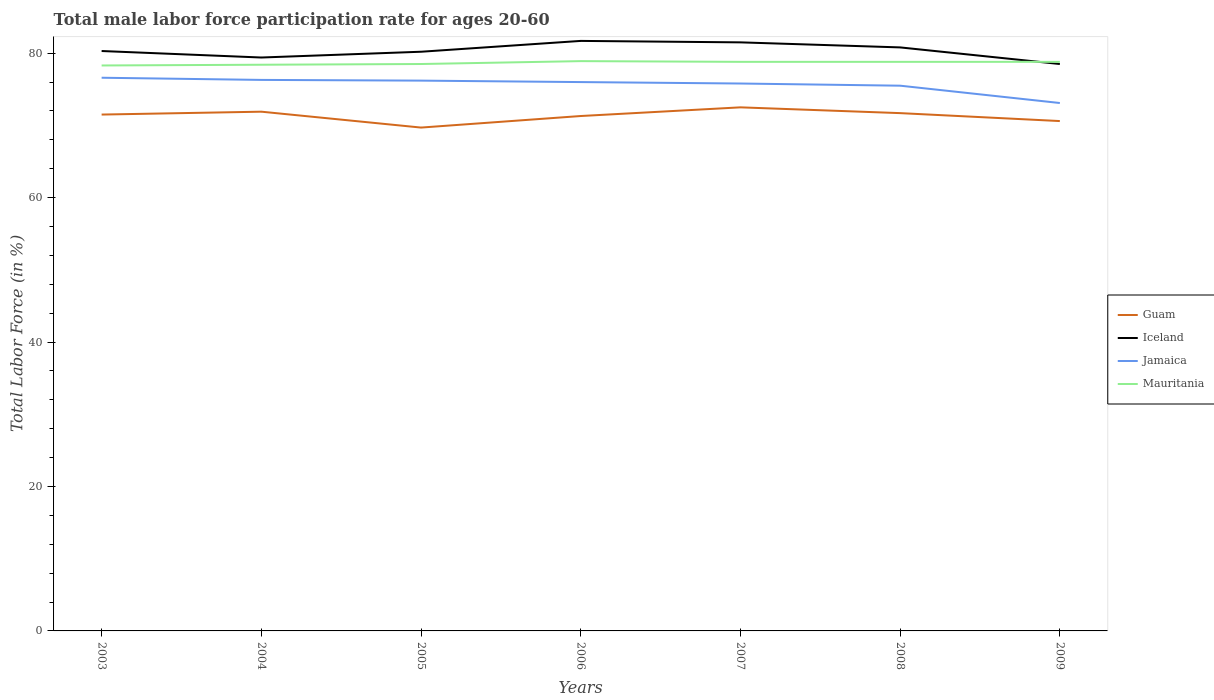How many different coloured lines are there?
Your answer should be very brief. 4. Across all years, what is the maximum male labor force participation rate in Guam?
Give a very brief answer. 69.7. In which year was the male labor force participation rate in Iceland maximum?
Make the answer very short. 2009. What is the difference between the highest and the second highest male labor force participation rate in Jamaica?
Provide a short and direct response. 3.5. What is the difference between the highest and the lowest male labor force participation rate in Iceland?
Keep it short and to the point. 3. Is the male labor force participation rate in Mauritania strictly greater than the male labor force participation rate in Iceland over the years?
Provide a short and direct response. No. How many lines are there?
Your answer should be very brief. 4. How many years are there in the graph?
Keep it short and to the point. 7. What is the difference between two consecutive major ticks on the Y-axis?
Your response must be concise. 20. Are the values on the major ticks of Y-axis written in scientific E-notation?
Give a very brief answer. No. Does the graph contain grids?
Offer a very short reply. No. Where does the legend appear in the graph?
Give a very brief answer. Center right. How many legend labels are there?
Offer a very short reply. 4. How are the legend labels stacked?
Offer a terse response. Vertical. What is the title of the graph?
Ensure brevity in your answer.  Total male labor force participation rate for ages 20-60. Does "Timor-Leste" appear as one of the legend labels in the graph?
Ensure brevity in your answer.  No. What is the label or title of the X-axis?
Provide a short and direct response. Years. What is the label or title of the Y-axis?
Your answer should be very brief. Total Labor Force (in %). What is the Total Labor Force (in %) in Guam in 2003?
Provide a short and direct response. 71.5. What is the Total Labor Force (in %) in Iceland in 2003?
Your response must be concise. 80.3. What is the Total Labor Force (in %) in Jamaica in 2003?
Offer a very short reply. 76.6. What is the Total Labor Force (in %) in Mauritania in 2003?
Your answer should be very brief. 78.3. What is the Total Labor Force (in %) in Guam in 2004?
Offer a very short reply. 71.9. What is the Total Labor Force (in %) in Iceland in 2004?
Your answer should be very brief. 79.4. What is the Total Labor Force (in %) of Jamaica in 2004?
Provide a short and direct response. 76.3. What is the Total Labor Force (in %) in Mauritania in 2004?
Ensure brevity in your answer.  78.4. What is the Total Labor Force (in %) of Guam in 2005?
Ensure brevity in your answer.  69.7. What is the Total Labor Force (in %) in Iceland in 2005?
Keep it short and to the point. 80.2. What is the Total Labor Force (in %) in Jamaica in 2005?
Offer a terse response. 76.2. What is the Total Labor Force (in %) in Mauritania in 2005?
Keep it short and to the point. 78.5. What is the Total Labor Force (in %) in Guam in 2006?
Make the answer very short. 71.3. What is the Total Labor Force (in %) in Iceland in 2006?
Offer a very short reply. 81.7. What is the Total Labor Force (in %) of Mauritania in 2006?
Your answer should be compact. 78.9. What is the Total Labor Force (in %) in Guam in 2007?
Your answer should be very brief. 72.5. What is the Total Labor Force (in %) in Iceland in 2007?
Provide a succinct answer. 81.5. What is the Total Labor Force (in %) in Jamaica in 2007?
Ensure brevity in your answer.  75.8. What is the Total Labor Force (in %) in Mauritania in 2007?
Give a very brief answer. 78.8. What is the Total Labor Force (in %) in Guam in 2008?
Your response must be concise. 71.7. What is the Total Labor Force (in %) in Iceland in 2008?
Your answer should be compact. 80.8. What is the Total Labor Force (in %) in Jamaica in 2008?
Your response must be concise. 75.5. What is the Total Labor Force (in %) in Mauritania in 2008?
Your answer should be compact. 78.8. What is the Total Labor Force (in %) of Guam in 2009?
Your answer should be compact. 70.6. What is the Total Labor Force (in %) of Iceland in 2009?
Offer a very short reply. 78.5. What is the Total Labor Force (in %) in Jamaica in 2009?
Provide a short and direct response. 73.1. What is the Total Labor Force (in %) of Mauritania in 2009?
Your answer should be compact. 78.8. Across all years, what is the maximum Total Labor Force (in %) in Guam?
Make the answer very short. 72.5. Across all years, what is the maximum Total Labor Force (in %) in Iceland?
Ensure brevity in your answer.  81.7. Across all years, what is the maximum Total Labor Force (in %) of Jamaica?
Keep it short and to the point. 76.6. Across all years, what is the maximum Total Labor Force (in %) of Mauritania?
Keep it short and to the point. 78.9. Across all years, what is the minimum Total Labor Force (in %) of Guam?
Ensure brevity in your answer.  69.7. Across all years, what is the minimum Total Labor Force (in %) in Iceland?
Provide a short and direct response. 78.5. Across all years, what is the minimum Total Labor Force (in %) in Jamaica?
Your answer should be very brief. 73.1. Across all years, what is the minimum Total Labor Force (in %) in Mauritania?
Your response must be concise. 78.3. What is the total Total Labor Force (in %) in Guam in the graph?
Provide a short and direct response. 499.2. What is the total Total Labor Force (in %) in Iceland in the graph?
Offer a terse response. 562.4. What is the total Total Labor Force (in %) of Jamaica in the graph?
Offer a very short reply. 529.5. What is the total Total Labor Force (in %) of Mauritania in the graph?
Your answer should be compact. 550.5. What is the difference between the Total Labor Force (in %) in Guam in 2003 and that in 2004?
Provide a short and direct response. -0.4. What is the difference between the Total Labor Force (in %) of Iceland in 2003 and that in 2004?
Provide a succinct answer. 0.9. What is the difference between the Total Labor Force (in %) of Iceland in 2003 and that in 2005?
Make the answer very short. 0.1. What is the difference between the Total Labor Force (in %) in Iceland in 2003 and that in 2006?
Keep it short and to the point. -1.4. What is the difference between the Total Labor Force (in %) in Jamaica in 2003 and that in 2006?
Make the answer very short. 0.6. What is the difference between the Total Labor Force (in %) of Iceland in 2003 and that in 2007?
Make the answer very short. -1.2. What is the difference between the Total Labor Force (in %) in Jamaica in 2003 and that in 2007?
Your answer should be very brief. 0.8. What is the difference between the Total Labor Force (in %) in Mauritania in 2003 and that in 2007?
Keep it short and to the point. -0.5. What is the difference between the Total Labor Force (in %) in Iceland in 2003 and that in 2008?
Offer a terse response. -0.5. What is the difference between the Total Labor Force (in %) in Jamaica in 2003 and that in 2008?
Offer a very short reply. 1.1. What is the difference between the Total Labor Force (in %) in Iceland in 2003 and that in 2009?
Your answer should be very brief. 1.8. What is the difference between the Total Labor Force (in %) in Iceland in 2004 and that in 2005?
Your response must be concise. -0.8. What is the difference between the Total Labor Force (in %) of Guam in 2004 and that in 2006?
Offer a very short reply. 0.6. What is the difference between the Total Labor Force (in %) in Jamaica in 2004 and that in 2006?
Make the answer very short. 0.3. What is the difference between the Total Labor Force (in %) in Guam in 2004 and that in 2007?
Your answer should be very brief. -0.6. What is the difference between the Total Labor Force (in %) in Jamaica in 2004 and that in 2007?
Make the answer very short. 0.5. What is the difference between the Total Labor Force (in %) in Guam in 2004 and that in 2008?
Your answer should be very brief. 0.2. What is the difference between the Total Labor Force (in %) in Jamaica in 2004 and that in 2008?
Offer a terse response. 0.8. What is the difference between the Total Labor Force (in %) in Mauritania in 2004 and that in 2008?
Provide a short and direct response. -0.4. What is the difference between the Total Labor Force (in %) in Guam in 2004 and that in 2009?
Ensure brevity in your answer.  1.3. What is the difference between the Total Labor Force (in %) in Guam in 2005 and that in 2006?
Your answer should be very brief. -1.6. What is the difference between the Total Labor Force (in %) of Jamaica in 2005 and that in 2006?
Your answer should be very brief. 0.2. What is the difference between the Total Labor Force (in %) in Mauritania in 2005 and that in 2006?
Give a very brief answer. -0.4. What is the difference between the Total Labor Force (in %) in Jamaica in 2005 and that in 2007?
Offer a terse response. 0.4. What is the difference between the Total Labor Force (in %) in Guam in 2005 and that in 2008?
Give a very brief answer. -2. What is the difference between the Total Labor Force (in %) in Iceland in 2005 and that in 2008?
Keep it short and to the point. -0.6. What is the difference between the Total Labor Force (in %) in Mauritania in 2005 and that in 2008?
Provide a succinct answer. -0.3. What is the difference between the Total Labor Force (in %) of Guam in 2005 and that in 2009?
Offer a very short reply. -0.9. What is the difference between the Total Labor Force (in %) of Iceland in 2005 and that in 2009?
Your response must be concise. 1.7. What is the difference between the Total Labor Force (in %) of Guam in 2006 and that in 2007?
Your answer should be compact. -1.2. What is the difference between the Total Labor Force (in %) of Jamaica in 2006 and that in 2007?
Your answer should be very brief. 0.2. What is the difference between the Total Labor Force (in %) of Guam in 2006 and that in 2008?
Offer a terse response. -0.4. What is the difference between the Total Labor Force (in %) in Guam in 2006 and that in 2009?
Your answer should be very brief. 0.7. What is the difference between the Total Labor Force (in %) of Mauritania in 2006 and that in 2009?
Offer a very short reply. 0.1. What is the difference between the Total Labor Force (in %) of Iceland in 2007 and that in 2008?
Provide a short and direct response. 0.7. What is the difference between the Total Labor Force (in %) in Jamaica in 2007 and that in 2008?
Make the answer very short. 0.3. What is the difference between the Total Labor Force (in %) in Mauritania in 2007 and that in 2009?
Provide a succinct answer. 0. What is the difference between the Total Labor Force (in %) in Guam in 2008 and that in 2009?
Offer a terse response. 1.1. What is the difference between the Total Labor Force (in %) of Iceland in 2008 and that in 2009?
Your answer should be compact. 2.3. What is the difference between the Total Labor Force (in %) in Jamaica in 2008 and that in 2009?
Your response must be concise. 2.4. What is the difference between the Total Labor Force (in %) in Mauritania in 2008 and that in 2009?
Your answer should be very brief. 0. What is the difference between the Total Labor Force (in %) in Guam in 2003 and the Total Labor Force (in %) in Iceland in 2004?
Keep it short and to the point. -7.9. What is the difference between the Total Labor Force (in %) in Guam in 2003 and the Total Labor Force (in %) in Mauritania in 2004?
Provide a short and direct response. -6.9. What is the difference between the Total Labor Force (in %) of Iceland in 2003 and the Total Labor Force (in %) of Jamaica in 2004?
Offer a very short reply. 4. What is the difference between the Total Labor Force (in %) in Jamaica in 2003 and the Total Labor Force (in %) in Mauritania in 2004?
Give a very brief answer. -1.8. What is the difference between the Total Labor Force (in %) in Guam in 2003 and the Total Labor Force (in %) in Iceland in 2005?
Provide a succinct answer. -8.7. What is the difference between the Total Labor Force (in %) of Iceland in 2003 and the Total Labor Force (in %) of Mauritania in 2005?
Offer a very short reply. 1.8. What is the difference between the Total Labor Force (in %) of Jamaica in 2003 and the Total Labor Force (in %) of Mauritania in 2005?
Provide a succinct answer. -1.9. What is the difference between the Total Labor Force (in %) in Guam in 2003 and the Total Labor Force (in %) in Jamaica in 2006?
Your response must be concise. -4.5. What is the difference between the Total Labor Force (in %) in Guam in 2003 and the Total Labor Force (in %) in Mauritania in 2006?
Keep it short and to the point. -7.4. What is the difference between the Total Labor Force (in %) of Iceland in 2003 and the Total Labor Force (in %) of Mauritania in 2006?
Provide a short and direct response. 1.4. What is the difference between the Total Labor Force (in %) in Jamaica in 2003 and the Total Labor Force (in %) in Mauritania in 2006?
Provide a short and direct response. -2.3. What is the difference between the Total Labor Force (in %) in Guam in 2003 and the Total Labor Force (in %) in Iceland in 2007?
Make the answer very short. -10. What is the difference between the Total Labor Force (in %) in Guam in 2003 and the Total Labor Force (in %) in Jamaica in 2007?
Provide a succinct answer. -4.3. What is the difference between the Total Labor Force (in %) in Guam in 2003 and the Total Labor Force (in %) in Iceland in 2008?
Offer a very short reply. -9.3. What is the difference between the Total Labor Force (in %) of Guam in 2003 and the Total Labor Force (in %) of Jamaica in 2008?
Give a very brief answer. -4. What is the difference between the Total Labor Force (in %) in Guam in 2003 and the Total Labor Force (in %) in Mauritania in 2008?
Keep it short and to the point. -7.3. What is the difference between the Total Labor Force (in %) of Iceland in 2003 and the Total Labor Force (in %) of Jamaica in 2008?
Ensure brevity in your answer.  4.8. What is the difference between the Total Labor Force (in %) of Iceland in 2003 and the Total Labor Force (in %) of Mauritania in 2009?
Give a very brief answer. 1.5. What is the difference between the Total Labor Force (in %) of Jamaica in 2003 and the Total Labor Force (in %) of Mauritania in 2009?
Provide a short and direct response. -2.2. What is the difference between the Total Labor Force (in %) in Guam in 2004 and the Total Labor Force (in %) in Iceland in 2005?
Your answer should be compact. -8.3. What is the difference between the Total Labor Force (in %) in Iceland in 2004 and the Total Labor Force (in %) in Jamaica in 2005?
Make the answer very short. 3.2. What is the difference between the Total Labor Force (in %) in Jamaica in 2004 and the Total Labor Force (in %) in Mauritania in 2005?
Provide a succinct answer. -2.2. What is the difference between the Total Labor Force (in %) of Guam in 2004 and the Total Labor Force (in %) of Iceland in 2006?
Provide a short and direct response. -9.8. What is the difference between the Total Labor Force (in %) in Guam in 2004 and the Total Labor Force (in %) in Jamaica in 2006?
Your response must be concise. -4.1. What is the difference between the Total Labor Force (in %) of Iceland in 2004 and the Total Labor Force (in %) of Jamaica in 2006?
Give a very brief answer. 3.4. What is the difference between the Total Labor Force (in %) in Iceland in 2004 and the Total Labor Force (in %) in Mauritania in 2006?
Make the answer very short. 0.5. What is the difference between the Total Labor Force (in %) of Jamaica in 2004 and the Total Labor Force (in %) of Mauritania in 2006?
Provide a short and direct response. -2.6. What is the difference between the Total Labor Force (in %) in Guam in 2004 and the Total Labor Force (in %) in Iceland in 2007?
Ensure brevity in your answer.  -9.6. What is the difference between the Total Labor Force (in %) of Iceland in 2004 and the Total Labor Force (in %) of Jamaica in 2007?
Ensure brevity in your answer.  3.6. What is the difference between the Total Labor Force (in %) of Iceland in 2004 and the Total Labor Force (in %) of Mauritania in 2007?
Offer a terse response. 0.6. What is the difference between the Total Labor Force (in %) in Iceland in 2004 and the Total Labor Force (in %) in Jamaica in 2008?
Your answer should be very brief. 3.9. What is the difference between the Total Labor Force (in %) of Jamaica in 2004 and the Total Labor Force (in %) of Mauritania in 2008?
Ensure brevity in your answer.  -2.5. What is the difference between the Total Labor Force (in %) in Guam in 2004 and the Total Labor Force (in %) in Iceland in 2009?
Offer a terse response. -6.6. What is the difference between the Total Labor Force (in %) of Guam in 2004 and the Total Labor Force (in %) of Jamaica in 2009?
Make the answer very short. -1.2. What is the difference between the Total Labor Force (in %) in Guam in 2004 and the Total Labor Force (in %) in Mauritania in 2009?
Give a very brief answer. -6.9. What is the difference between the Total Labor Force (in %) of Iceland in 2004 and the Total Labor Force (in %) of Jamaica in 2009?
Ensure brevity in your answer.  6.3. What is the difference between the Total Labor Force (in %) in Iceland in 2004 and the Total Labor Force (in %) in Mauritania in 2009?
Give a very brief answer. 0.6. What is the difference between the Total Labor Force (in %) in Jamaica in 2004 and the Total Labor Force (in %) in Mauritania in 2009?
Offer a terse response. -2.5. What is the difference between the Total Labor Force (in %) of Guam in 2005 and the Total Labor Force (in %) of Iceland in 2006?
Provide a short and direct response. -12. What is the difference between the Total Labor Force (in %) in Guam in 2005 and the Total Labor Force (in %) in Jamaica in 2006?
Make the answer very short. -6.3. What is the difference between the Total Labor Force (in %) of Guam in 2005 and the Total Labor Force (in %) of Mauritania in 2006?
Your answer should be compact. -9.2. What is the difference between the Total Labor Force (in %) of Jamaica in 2005 and the Total Labor Force (in %) of Mauritania in 2006?
Keep it short and to the point. -2.7. What is the difference between the Total Labor Force (in %) in Guam in 2005 and the Total Labor Force (in %) in Iceland in 2007?
Your answer should be compact. -11.8. What is the difference between the Total Labor Force (in %) of Guam in 2005 and the Total Labor Force (in %) of Jamaica in 2007?
Offer a very short reply. -6.1. What is the difference between the Total Labor Force (in %) in Guam in 2005 and the Total Labor Force (in %) in Mauritania in 2007?
Ensure brevity in your answer.  -9.1. What is the difference between the Total Labor Force (in %) in Guam in 2005 and the Total Labor Force (in %) in Jamaica in 2008?
Your answer should be very brief. -5.8. What is the difference between the Total Labor Force (in %) in Guam in 2005 and the Total Labor Force (in %) in Mauritania in 2008?
Offer a very short reply. -9.1. What is the difference between the Total Labor Force (in %) of Iceland in 2005 and the Total Labor Force (in %) of Jamaica in 2008?
Offer a terse response. 4.7. What is the difference between the Total Labor Force (in %) in Guam in 2005 and the Total Labor Force (in %) in Iceland in 2009?
Keep it short and to the point. -8.8. What is the difference between the Total Labor Force (in %) of Guam in 2005 and the Total Labor Force (in %) of Jamaica in 2009?
Offer a very short reply. -3.4. What is the difference between the Total Labor Force (in %) in Guam in 2005 and the Total Labor Force (in %) in Mauritania in 2009?
Provide a succinct answer. -9.1. What is the difference between the Total Labor Force (in %) of Jamaica in 2005 and the Total Labor Force (in %) of Mauritania in 2009?
Offer a terse response. -2.6. What is the difference between the Total Labor Force (in %) of Guam in 2006 and the Total Labor Force (in %) of Iceland in 2007?
Ensure brevity in your answer.  -10.2. What is the difference between the Total Labor Force (in %) in Guam in 2006 and the Total Labor Force (in %) in Jamaica in 2007?
Provide a succinct answer. -4.5. What is the difference between the Total Labor Force (in %) in Guam in 2006 and the Total Labor Force (in %) in Mauritania in 2007?
Provide a short and direct response. -7.5. What is the difference between the Total Labor Force (in %) of Iceland in 2006 and the Total Labor Force (in %) of Mauritania in 2007?
Make the answer very short. 2.9. What is the difference between the Total Labor Force (in %) of Guam in 2006 and the Total Labor Force (in %) of Iceland in 2008?
Offer a terse response. -9.5. What is the difference between the Total Labor Force (in %) of Guam in 2006 and the Total Labor Force (in %) of Jamaica in 2008?
Provide a succinct answer. -4.2. What is the difference between the Total Labor Force (in %) in Guam in 2006 and the Total Labor Force (in %) in Mauritania in 2008?
Provide a succinct answer. -7.5. What is the difference between the Total Labor Force (in %) in Guam in 2006 and the Total Labor Force (in %) in Iceland in 2009?
Keep it short and to the point. -7.2. What is the difference between the Total Labor Force (in %) in Guam in 2006 and the Total Labor Force (in %) in Mauritania in 2009?
Ensure brevity in your answer.  -7.5. What is the difference between the Total Labor Force (in %) of Iceland in 2006 and the Total Labor Force (in %) of Mauritania in 2009?
Offer a terse response. 2.9. What is the difference between the Total Labor Force (in %) in Jamaica in 2006 and the Total Labor Force (in %) in Mauritania in 2009?
Your answer should be very brief. -2.8. What is the difference between the Total Labor Force (in %) of Guam in 2007 and the Total Labor Force (in %) of Jamaica in 2008?
Offer a terse response. -3. What is the difference between the Total Labor Force (in %) in Iceland in 2007 and the Total Labor Force (in %) in Mauritania in 2008?
Ensure brevity in your answer.  2.7. What is the difference between the Total Labor Force (in %) of Guam in 2007 and the Total Labor Force (in %) of Jamaica in 2009?
Your answer should be compact. -0.6. What is the difference between the Total Labor Force (in %) in Iceland in 2007 and the Total Labor Force (in %) in Jamaica in 2009?
Give a very brief answer. 8.4. What is the difference between the Total Labor Force (in %) of Iceland in 2007 and the Total Labor Force (in %) of Mauritania in 2009?
Your answer should be compact. 2.7. What is the difference between the Total Labor Force (in %) in Jamaica in 2007 and the Total Labor Force (in %) in Mauritania in 2009?
Ensure brevity in your answer.  -3. What is the difference between the Total Labor Force (in %) of Guam in 2008 and the Total Labor Force (in %) of Iceland in 2009?
Provide a succinct answer. -6.8. What is the difference between the Total Labor Force (in %) in Guam in 2008 and the Total Labor Force (in %) in Mauritania in 2009?
Your answer should be very brief. -7.1. What is the difference between the Total Labor Force (in %) in Iceland in 2008 and the Total Labor Force (in %) in Mauritania in 2009?
Offer a terse response. 2. What is the average Total Labor Force (in %) of Guam per year?
Provide a succinct answer. 71.31. What is the average Total Labor Force (in %) in Iceland per year?
Your answer should be compact. 80.34. What is the average Total Labor Force (in %) in Jamaica per year?
Make the answer very short. 75.64. What is the average Total Labor Force (in %) in Mauritania per year?
Give a very brief answer. 78.64. In the year 2003, what is the difference between the Total Labor Force (in %) of Guam and Total Labor Force (in %) of Mauritania?
Ensure brevity in your answer.  -6.8. In the year 2003, what is the difference between the Total Labor Force (in %) in Iceland and Total Labor Force (in %) in Jamaica?
Offer a terse response. 3.7. In the year 2003, what is the difference between the Total Labor Force (in %) of Jamaica and Total Labor Force (in %) of Mauritania?
Make the answer very short. -1.7. In the year 2004, what is the difference between the Total Labor Force (in %) of Guam and Total Labor Force (in %) of Iceland?
Keep it short and to the point. -7.5. In the year 2004, what is the difference between the Total Labor Force (in %) of Iceland and Total Labor Force (in %) of Mauritania?
Offer a terse response. 1. In the year 2005, what is the difference between the Total Labor Force (in %) in Guam and Total Labor Force (in %) in Mauritania?
Ensure brevity in your answer.  -8.8. In the year 2005, what is the difference between the Total Labor Force (in %) in Iceland and Total Labor Force (in %) in Jamaica?
Provide a succinct answer. 4. In the year 2005, what is the difference between the Total Labor Force (in %) in Jamaica and Total Labor Force (in %) in Mauritania?
Offer a terse response. -2.3. In the year 2006, what is the difference between the Total Labor Force (in %) of Guam and Total Labor Force (in %) of Iceland?
Give a very brief answer. -10.4. In the year 2006, what is the difference between the Total Labor Force (in %) in Guam and Total Labor Force (in %) in Jamaica?
Make the answer very short. -4.7. In the year 2006, what is the difference between the Total Labor Force (in %) in Iceland and Total Labor Force (in %) in Jamaica?
Offer a very short reply. 5.7. In the year 2006, what is the difference between the Total Labor Force (in %) of Jamaica and Total Labor Force (in %) of Mauritania?
Ensure brevity in your answer.  -2.9. In the year 2007, what is the difference between the Total Labor Force (in %) of Guam and Total Labor Force (in %) of Iceland?
Provide a short and direct response. -9. In the year 2007, what is the difference between the Total Labor Force (in %) of Guam and Total Labor Force (in %) of Jamaica?
Your answer should be very brief. -3.3. In the year 2007, what is the difference between the Total Labor Force (in %) of Guam and Total Labor Force (in %) of Mauritania?
Give a very brief answer. -6.3. In the year 2007, what is the difference between the Total Labor Force (in %) in Iceland and Total Labor Force (in %) in Mauritania?
Offer a very short reply. 2.7. In the year 2008, what is the difference between the Total Labor Force (in %) of Guam and Total Labor Force (in %) of Mauritania?
Offer a terse response. -7.1. In the year 2008, what is the difference between the Total Labor Force (in %) in Iceland and Total Labor Force (in %) in Jamaica?
Your answer should be compact. 5.3. In the year 2008, what is the difference between the Total Labor Force (in %) in Iceland and Total Labor Force (in %) in Mauritania?
Make the answer very short. 2. In the year 2009, what is the difference between the Total Labor Force (in %) of Guam and Total Labor Force (in %) of Mauritania?
Ensure brevity in your answer.  -8.2. In the year 2009, what is the difference between the Total Labor Force (in %) in Iceland and Total Labor Force (in %) in Jamaica?
Your response must be concise. 5.4. In the year 2009, what is the difference between the Total Labor Force (in %) of Iceland and Total Labor Force (in %) of Mauritania?
Keep it short and to the point. -0.3. In the year 2009, what is the difference between the Total Labor Force (in %) of Jamaica and Total Labor Force (in %) of Mauritania?
Offer a very short reply. -5.7. What is the ratio of the Total Labor Force (in %) of Guam in 2003 to that in 2004?
Provide a short and direct response. 0.99. What is the ratio of the Total Labor Force (in %) of Iceland in 2003 to that in 2004?
Ensure brevity in your answer.  1.01. What is the ratio of the Total Labor Force (in %) of Guam in 2003 to that in 2005?
Offer a very short reply. 1.03. What is the ratio of the Total Labor Force (in %) of Iceland in 2003 to that in 2005?
Provide a succinct answer. 1. What is the ratio of the Total Labor Force (in %) of Jamaica in 2003 to that in 2005?
Offer a terse response. 1.01. What is the ratio of the Total Labor Force (in %) in Mauritania in 2003 to that in 2005?
Ensure brevity in your answer.  1. What is the ratio of the Total Labor Force (in %) of Iceland in 2003 to that in 2006?
Make the answer very short. 0.98. What is the ratio of the Total Labor Force (in %) in Jamaica in 2003 to that in 2006?
Ensure brevity in your answer.  1.01. What is the ratio of the Total Labor Force (in %) of Guam in 2003 to that in 2007?
Your answer should be very brief. 0.99. What is the ratio of the Total Labor Force (in %) of Iceland in 2003 to that in 2007?
Your response must be concise. 0.99. What is the ratio of the Total Labor Force (in %) of Jamaica in 2003 to that in 2007?
Your answer should be very brief. 1.01. What is the ratio of the Total Labor Force (in %) of Mauritania in 2003 to that in 2007?
Make the answer very short. 0.99. What is the ratio of the Total Labor Force (in %) of Jamaica in 2003 to that in 2008?
Offer a terse response. 1.01. What is the ratio of the Total Labor Force (in %) of Guam in 2003 to that in 2009?
Give a very brief answer. 1.01. What is the ratio of the Total Labor Force (in %) of Iceland in 2003 to that in 2009?
Keep it short and to the point. 1.02. What is the ratio of the Total Labor Force (in %) of Jamaica in 2003 to that in 2009?
Your response must be concise. 1.05. What is the ratio of the Total Labor Force (in %) in Guam in 2004 to that in 2005?
Make the answer very short. 1.03. What is the ratio of the Total Labor Force (in %) of Iceland in 2004 to that in 2005?
Keep it short and to the point. 0.99. What is the ratio of the Total Labor Force (in %) in Guam in 2004 to that in 2006?
Your answer should be compact. 1.01. What is the ratio of the Total Labor Force (in %) of Iceland in 2004 to that in 2006?
Your answer should be compact. 0.97. What is the ratio of the Total Labor Force (in %) of Mauritania in 2004 to that in 2006?
Offer a very short reply. 0.99. What is the ratio of the Total Labor Force (in %) in Iceland in 2004 to that in 2007?
Give a very brief answer. 0.97. What is the ratio of the Total Labor Force (in %) of Jamaica in 2004 to that in 2007?
Give a very brief answer. 1.01. What is the ratio of the Total Labor Force (in %) in Mauritania in 2004 to that in 2007?
Make the answer very short. 0.99. What is the ratio of the Total Labor Force (in %) in Iceland in 2004 to that in 2008?
Ensure brevity in your answer.  0.98. What is the ratio of the Total Labor Force (in %) of Jamaica in 2004 to that in 2008?
Offer a terse response. 1.01. What is the ratio of the Total Labor Force (in %) in Mauritania in 2004 to that in 2008?
Give a very brief answer. 0.99. What is the ratio of the Total Labor Force (in %) in Guam in 2004 to that in 2009?
Make the answer very short. 1.02. What is the ratio of the Total Labor Force (in %) of Iceland in 2004 to that in 2009?
Your answer should be compact. 1.01. What is the ratio of the Total Labor Force (in %) in Jamaica in 2004 to that in 2009?
Provide a succinct answer. 1.04. What is the ratio of the Total Labor Force (in %) of Guam in 2005 to that in 2006?
Your response must be concise. 0.98. What is the ratio of the Total Labor Force (in %) in Iceland in 2005 to that in 2006?
Provide a short and direct response. 0.98. What is the ratio of the Total Labor Force (in %) in Mauritania in 2005 to that in 2006?
Your answer should be compact. 0.99. What is the ratio of the Total Labor Force (in %) in Guam in 2005 to that in 2007?
Offer a terse response. 0.96. What is the ratio of the Total Labor Force (in %) of Jamaica in 2005 to that in 2007?
Ensure brevity in your answer.  1.01. What is the ratio of the Total Labor Force (in %) of Mauritania in 2005 to that in 2007?
Offer a terse response. 1. What is the ratio of the Total Labor Force (in %) in Guam in 2005 to that in 2008?
Give a very brief answer. 0.97. What is the ratio of the Total Labor Force (in %) in Jamaica in 2005 to that in 2008?
Provide a short and direct response. 1.01. What is the ratio of the Total Labor Force (in %) in Mauritania in 2005 to that in 2008?
Provide a succinct answer. 1. What is the ratio of the Total Labor Force (in %) of Guam in 2005 to that in 2009?
Your answer should be very brief. 0.99. What is the ratio of the Total Labor Force (in %) in Iceland in 2005 to that in 2009?
Provide a succinct answer. 1.02. What is the ratio of the Total Labor Force (in %) in Jamaica in 2005 to that in 2009?
Make the answer very short. 1.04. What is the ratio of the Total Labor Force (in %) of Guam in 2006 to that in 2007?
Provide a succinct answer. 0.98. What is the ratio of the Total Labor Force (in %) of Iceland in 2006 to that in 2007?
Give a very brief answer. 1. What is the ratio of the Total Labor Force (in %) of Mauritania in 2006 to that in 2007?
Offer a very short reply. 1. What is the ratio of the Total Labor Force (in %) in Iceland in 2006 to that in 2008?
Offer a terse response. 1.01. What is the ratio of the Total Labor Force (in %) in Jamaica in 2006 to that in 2008?
Provide a succinct answer. 1.01. What is the ratio of the Total Labor Force (in %) in Guam in 2006 to that in 2009?
Your answer should be compact. 1.01. What is the ratio of the Total Labor Force (in %) of Iceland in 2006 to that in 2009?
Keep it short and to the point. 1.04. What is the ratio of the Total Labor Force (in %) of Jamaica in 2006 to that in 2009?
Keep it short and to the point. 1.04. What is the ratio of the Total Labor Force (in %) in Guam in 2007 to that in 2008?
Offer a terse response. 1.01. What is the ratio of the Total Labor Force (in %) of Iceland in 2007 to that in 2008?
Offer a terse response. 1.01. What is the ratio of the Total Labor Force (in %) in Jamaica in 2007 to that in 2008?
Offer a very short reply. 1. What is the ratio of the Total Labor Force (in %) in Guam in 2007 to that in 2009?
Your response must be concise. 1.03. What is the ratio of the Total Labor Force (in %) of Iceland in 2007 to that in 2009?
Offer a very short reply. 1.04. What is the ratio of the Total Labor Force (in %) of Jamaica in 2007 to that in 2009?
Provide a succinct answer. 1.04. What is the ratio of the Total Labor Force (in %) of Mauritania in 2007 to that in 2009?
Keep it short and to the point. 1. What is the ratio of the Total Labor Force (in %) in Guam in 2008 to that in 2009?
Keep it short and to the point. 1.02. What is the ratio of the Total Labor Force (in %) in Iceland in 2008 to that in 2009?
Provide a short and direct response. 1.03. What is the ratio of the Total Labor Force (in %) in Jamaica in 2008 to that in 2009?
Provide a short and direct response. 1.03. What is the difference between the highest and the second highest Total Labor Force (in %) in Iceland?
Make the answer very short. 0.2. What is the difference between the highest and the second highest Total Labor Force (in %) of Mauritania?
Keep it short and to the point. 0.1. What is the difference between the highest and the lowest Total Labor Force (in %) of Iceland?
Your response must be concise. 3.2. What is the difference between the highest and the lowest Total Labor Force (in %) of Mauritania?
Give a very brief answer. 0.6. 